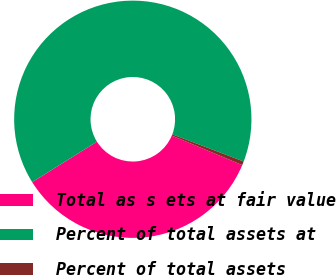Convert chart. <chart><loc_0><loc_0><loc_500><loc_500><pie_chart><fcel>Total as s ets at fair value<fcel>Percent of total assets at<fcel>Percent of total assets<nl><fcel>34.8%<fcel>64.68%<fcel>0.52%<nl></chart> 